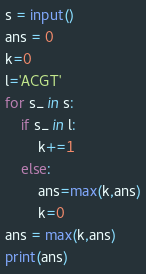Convert code to text. <code><loc_0><loc_0><loc_500><loc_500><_Python_>s = input()
ans = 0
k=0
l='ACGT'
for s_ in s:
    if s_ in l:
        k+=1
    else:
        ans=max(k,ans)
        k=0
ans = max(k,ans)
print(ans)</code> 